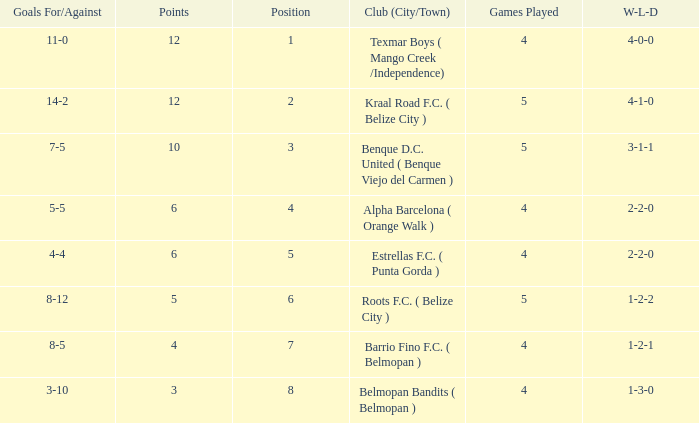What's the w-l-d with position being 1 4-0-0. 